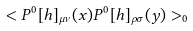<formula> <loc_0><loc_0><loc_500><loc_500>< P ^ { 0 } [ h ] _ { \mu \nu } ( x ) P ^ { 0 } [ h ] _ { \rho \sigma } ( y ) > _ { 0 }</formula> 